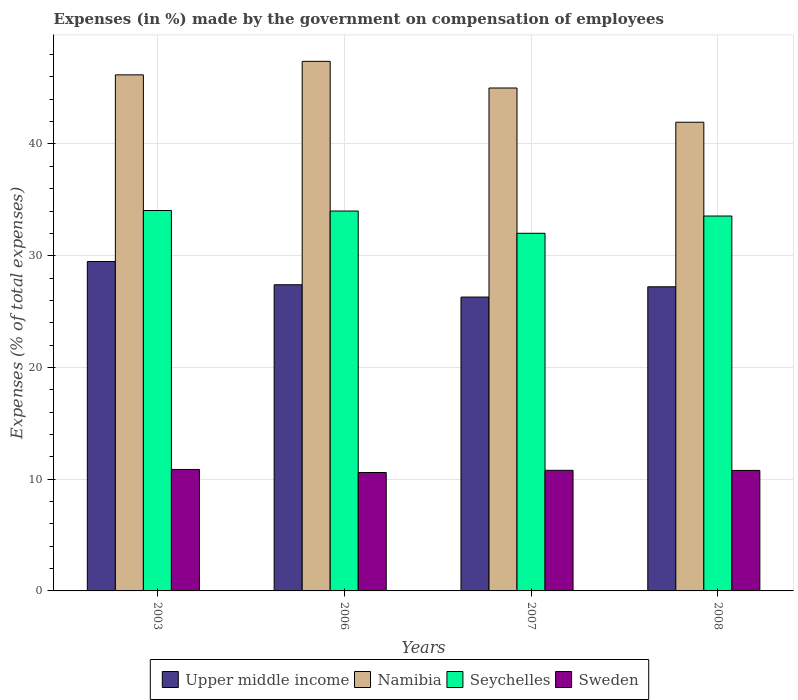How many different coloured bars are there?
Provide a succinct answer. 4. How many groups of bars are there?
Give a very brief answer. 4. How many bars are there on the 4th tick from the left?
Your answer should be compact. 4. How many bars are there on the 4th tick from the right?
Your answer should be very brief. 4. What is the percentage of expenses made by the government on compensation of employees in Upper middle income in 2007?
Offer a terse response. 26.3. Across all years, what is the maximum percentage of expenses made by the government on compensation of employees in Sweden?
Offer a terse response. 10.87. Across all years, what is the minimum percentage of expenses made by the government on compensation of employees in Upper middle income?
Offer a terse response. 26.3. In which year was the percentage of expenses made by the government on compensation of employees in Sweden maximum?
Your answer should be compact. 2003. In which year was the percentage of expenses made by the government on compensation of employees in Upper middle income minimum?
Provide a succinct answer. 2007. What is the total percentage of expenses made by the government on compensation of employees in Sweden in the graph?
Your answer should be very brief. 43.05. What is the difference between the percentage of expenses made by the government on compensation of employees in Seychelles in 2003 and that in 2007?
Offer a very short reply. 2.04. What is the difference between the percentage of expenses made by the government on compensation of employees in Upper middle income in 2007 and the percentage of expenses made by the government on compensation of employees in Sweden in 2003?
Offer a very short reply. 15.43. What is the average percentage of expenses made by the government on compensation of employees in Sweden per year?
Keep it short and to the point. 10.76. In the year 2006, what is the difference between the percentage of expenses made by the government on compensation of employees in Sweden and percentage of expenses made by the government on compensation of employees in Namibia?
Give a very brief answer. -36.8. In how many years, is the percentage of expenses made by the government on compensation of employees in Seychelles greater than 14 %?
Make the answer very short. 4. What is the ratio of the percentage of expenses made by the government on compensation of employees in Upper middle income in 2003 to that in 2007?
Make the answer very short. 1.12. Is the percentage of expenses made by the government on compensation of employees in Sweden in 2003 less than that in 2007?
Your response must be concise. No. Is the difference between the percentage of expenses made by the government on compensation of employees in Sweden in 2003 and 2008 greater than the difference between the percentage of expenses made by the government on compensation of employees in Namibia in 2003 and 2008?
Offer a terse response. No. What is the difference between the highest and the second highest percentage of expenses made by the government on compensation of employees in Namibia?
Ensure brevity in your answer.  1.21. What is the difference between the highest and the lowest percentage of expenses made by the government on compensation of employees in Seychelles?
Your answer should be compact. 2.04. In how many years, is the percentage of expenses made by the government on compensation of employees in Namibia greater than the average percentage of expenses made by the government on compensation of employees in Namibia taken over all years?
Provide a succinct answer. 2. Is the sum of the percentage of expenses made by the government on compensation of employees in Seychelles in 2006 and 2008 greater than the maximum percentage of expenses made by the government on compensation of employees in Namibia across all years?
Your answer should be very brief. Yes. Is it the case that in every year, the sum of the percentage of expenses made by the government on compensation of employees in Sweden and percentage of expenses made by the government on compensation of employees in Namibia is greater than the sum of percentage of expenses made by the government on compensation of employees in Seychelles and percentage of expenses made by the government on compensation of employees in Upper middle income?
Give a very brief answer. No. What does the 4th bar from the left in 2008 represents?
Make the answer very short. Sweden. What does the 2nd bar from the right in 2006 represents?
Offer a terse response. Seychelles. How many bars are there?
Your response must be concise. 16. Are all the bars in the graph horizontal?
Give a very brief answer. No. How many years are there in the graph?
Your response must be concise. 4. Are the values on the major ticks of Y-axis written in scientific E-notation?
Make the answer very short. No. Does the graph contain any zero values?
Provide a short and direct response. No. How are the legend labels stacked?
Your answer should be very brief. Horizontal. What is the title of the graph?
Offer a terse response. Expenses (in %) made by the government on compensation of employees. What is the label or title of the Y-axis?
Provide a short and direct response. Expenses (% of total expenses). What is the Expenses (% of total expenses) of Upper middle income in 2003?
Provide a succinct answer. 29.48. What is the Expenses (% of total expenses) in Namibia in 2003?
Offer a very short reply. 46.19. What is the Expenses (% of total expenses) in Seychelles in 2003?
Your answer should be compact. 34.05. What is the Expenses (% of total expenses) in Sweden in 2003?
Offer a terse response. 10.87. What is the Expenses (% of total expenses) in Upper middle income in 2006?
Keep it short and to the point. 27.4. What is the Expenses (% of total expenses) of Namibia in 2006?
Give a very brief answer. 47.4. What is the Expenses (% of total expenses) in Seychelles in 2006?
Your response must be concise. 34. What is the Expenses (% of total expenses) in Sweden in 2006?
Make the answer very short. 10.6. What is the Expenses (% of total expenses) in Upper middle income in 2007?
Ensure brevity in your answer.  26.3. What is the Expenses (% of total expenses) of Namibia in 2007?
Give a very brief answer. 45.01. What is the Expenses (% of total expenses) in Seychelles in 2007?
Your response must be concise. 32.01. What is the Expenses (% of total expenses) in Sweden in 2007?
Give a very brief answer. 10.79. What is the Expenses (% of total expenses) in Upper middle income in 2008?
Give a very brief answer. 27.22. What is the Expenses (% of total expenses) of Namibia in 2008?
Provide a succinct answer. 41.95. What is the Expenses (% of total expenses) of Seychelles in 2008?
Offer a terse response. 33.55. What is the Expenses (% of total expenses) of Sweden in 2008?
Ensure brevity in your answer.  10.78. Across all years, what is the maximum Expenses (% of total expenses) in Upper middle income?
Give a very brief answer. 29.48. Across all years, what is the maximum Expenses (% of total expenses) of Namibia?
Provide a short and direct response. 47.4. Across all years, what is the maximum Expenses (% of total expenses) in Seychelles?
Make the answer very short. 34.05. Across all years, what is the maximum Expenses (% of total expenses) in Sweden?
Provide a succinct answer. 10.87. Across all years, what is the minimum Expenses (% of total expenses) in Upper middle income?
Make the answer very short. 26.3. Across all years, what is the minimum Expenses (% of total expenses) of Namibia?
Make the answer very short. 41.95. Across all years, what is the minimum Expenses (% of total expenses) in Seychelles?
Make the answer very short. 32.01. Across all years, what is the minimum Expenses (% of total expenses) in Sweden?
Your answer should be very brief. 10.6. What is the total Expenses (% of total expenses) of Upper middle income in the graph?
Keep it short and to the point. 110.4. What is the total Expenses (% of total expenses) in Namibia in the graph?
Your answer should be compact. 180.54. What is the total Expenses (% of total expenses) in Seychelles in the graph?
Your response must be concise. 133.61. What is the total Expenses (% of total expenses) in Sweden in the graph?
Make the answer very short. 43.05. What is the difference between the Expenses (% of total expenses) of Upper middle income in 2003 and that in 2006?
Offer a very short reply. 2.08. What is the difference between the Expenses (% of total expenses) in Namibia in 2003 and that in 2006?
Offer a very short reply. -1.21. What is the difference between the Expenses (% of total expenses) in Seychelles in 2003 and that in 2006?
Ensure brevity in your answer.  0.05. What is the difference between the Expenses (% of total expenses) in Sweden in 2003 and that in 2006?
Make the answer very short. 0.27. What is the difference between the Expenses (% of total expenses) of Upper middle income in 2003 and that in 2007?
Keep it short and to the point. 3.18. What is the difference between the Expenses (% of total expenses) in Namibia in 2003 and that in 2007?
Offer a very short reply. 1.18. What is the difference between the Expenses (% of total expenses) of Seychelles in 2003 and that in 2007?
Provide a short and direct response. 2.04. What is the difference between the Expenses (% of total expenses) in Sweden in 2003 and that in 2007?
Provide a succinct answer. 0.08. What is the difference between the Expenses (% of total expenses) in Upper middle income in 2003 and that in 2008?
Make the answer very short. 2.26. What is the difference between the Expenses (% of total expenses) of Namibia in 2003 and that in 2008?
Ensure brevity in your answer.  4.24. What is the difference between the Expenses (% of total expenses) in Seychelles in 2003 and that in 2008?
Give a very brief answer. 0.49. What is the difference between the Expenses (% of total expenses) in Sweden in 2003 and that in 2008?
Offer a terse response. 0.09. What is the difference between the Expenses (% of total expenses) of Upper middle income in 2006 and that in 2007?
Give a very brief answer. 1.1. What is the difference between the Expenses (% of total expenses) of Namibia in 2006 and that in 2007?
Your response must be concise. 2.39. What is the difference between the Expenses (% of total expenses) in Seychelles in 2006 and that in 2007?
Offer a very short reply. 1.99. What is the difference between the Expenses (% of total expenses) in Sweden in 2006 and that in 2007?
Ensure brevity in your answer.  -0.2. What is the difference between the Expenses (% of total expenses) of Upper middle income in 2006 and that in 2008?
Provide a short and direct response. 0.18. What is the difference between the Expenses (% of total expenses) in Namibia in 2006 and that in 2008?
Offer a terse response. 5.45. What is the difference between the Expenses (% of total expenses) in Seychelles in 2006 and that in 2008?
Your answer should be very brief. 0.45. What is the difference between the Expenses (% of total expenses) of Sweden in 2006 and that in 2008?
Your answer should be compact. -0.19. What is the difference between the Expenses (% of total expenses) in Upper middle income in 2007 and that in 2008?
Your answer should be compact. -0.92. What is the difference between the Expenses (% of total expenses) of Namibia in 2007 and that in 2008?
Give a very brief answer. 3.06. What is the difference between the Expenses (% of total expenses) of Seychelles in 2007 and that in 2008?
Give a very brief answer. -1.55. What is the difference between the Expenses (% of total expenses) of Sweden in 2007 and that in 2008?
Offer a terse response. 0.01. What is the difference between the Expenses (% of total expenses) of Upper middle income in 2003 and the Expenses (% of total expenses) of Namibia in 2006?
Give a very brief answer. -17.91. What is the difference between the Expenses (% of total expenses) in Upper middle income in 2003 and the Expenses (% of total expenses) in Seychelles in 2006?
Your answer should be compact. -4.52. What is the difference between the Expenses (% of total expenses) of Upper middle income in 2003 and the Expenses (% of total expenses) of Sweden in 2006?
Keep it short and to the point. 18.89. What is the difference between the Expenses (% of total expenses) of Namibia in 2003 and the Expenses (% of total expenses) of Seychelles in 2006?
Your response must be concise. 12.19. What is the difference between the Expenses (% of total expenses) of Namibia in 2003 and the Expenses (% of total expenses) of Sweden in 2006?
Provide a succinct answer. 35.59. What is the difference between the Expenses (% of total expenses) of Seychelles in 2003 and the Expenses (% of total expenses) of Sweden in 2006?
Your response must be concise. 23.45. What is the difference between the Expenses (% of total expenses) of Upper middle income in 2003 and the Expenses (% of total expenses) of Namibia in 2007?
Your answer should be very brief. -15.53. What is the difference between the Expenses (% of total expenses) of Upper middle income in 2003 and the Expenses (% of total expenses) of Seychelles in 2007?
Ensure brevity in your answer.  -2.52. What is the difference between the Expenses (% of total expenses) of Upper middle income in 2003 and the Expenses (% of total expenses) of Sweden in 2007?
Offer a terse response. 18.69. What is the difference between the Expenses (% of total expenses) in Namibia in 2003 and the Expenses (% of total expenses) in Seychelles in 2007?
Ensure brevity in your answer.  14.18. What is the difference between the Expenses (% of total expenses) in Namibia in 2003 and the Expenses (% of total expenses) in Sweden in 2007?
Offer a very short reply. 35.39. What is the difference between the Expenses (% of total expenses) of Seychelles in 2003 and the Expenses (% of total expenses) of Sweden in 2007?
Your response must be concise. 23.25. What is the difference between the Expenses (% of total expenses) of Upper middle income in 2003 and the Expenses (% of total expenses) of Namibia in 2008?
Keep it short and to the point. -12.46. What is the difference between the Expenses (% of total expenses) in Upper middle income in 2003 and the Expenses (% of total expenses) in Seychelles in 2008?
Make the answer very short. -4.07. What is the difference between the Expenses (% of total expenses) of Upper middle income in 2003 and the Expenses (% of total expenses) of Sweden in 2008?
Your answer should be compact. 18.7. What is the difference between the Expenses (% of total expenses) in Namibia in 2003 and the Expenses (% of total expenses) in Seychelles in 2008?
Give a very brief answer. 12.63. What is the difference between the Expenses (% of total expenses) in Namibia in 2003 and the Expenses (% of total expenses) in Sweden in 2008?
Keep it short and to the point. 35.4. What is the difference between the Expenses (% of total expenses) in Seychelles in 2003 and the Expenses (% of total expenses) in Sweden in 2008?
Provide a short and direct response. 23.26. What is the difference between the Expenses (% of total expenses) in Upper middle income in 2006 and the Expenses (% of total expenses) in Namibia in 2007?
Ensure brevity in your answer.  -17.61. What is the difference between the Expenses (% of total expenses) of Upper middle income in 2006 and the Expenses (% of total expenses) of Seychelles in 2007?
Offer a very short reply. -4.61. What is the difference between the Expenses (% of total expenses) in Upper middle income in 2006 and the Expenses (% of total expenses) in Sweden in 2007?
Your answer should be compact. 16.61. What is the difference between the Expenses (% of total expenses) in Namibia in 2006 and the Expenses (% of total expenses) in Seychelles in 2007?
Provide a short and direct response. 15.39. What is the difference between the Expenses (% of total expenses) of Namibia in 2006 and the Expenses (% of total expenses) of Sweden in 2007?
Make the answer very short. 36.6. What is the difference between the Expenses (% of total expenses) of Seychelles in 2006 and the Expenses (% of total expenses) of Sweden in 2007?
Keep it short and to the point. 23.21. What is the difference between the Expenses (% of total expenses) in Upper middle income in 2006 and the Expenses (% of total expenses) in Namibia in 2008?
Your answer should be compact. -14.55. What is the difference between the Expenses (% of total expenses) in Upper middle income in 2006 and the Expenses (% of total expenses) in Seychelles in 2008?
Offer a very short reply. -6.15. What is the difference between the Expenses (% of total expenses) in Upper middle income in 2006 and the Expenses (% of total expenses) in Sweden in 2008?
Provide a succinct answer. 16.62. What is the difference between the Expenses (% of total expenses) of Namibia in 2006 and the Expenses (% of total expenses) of Seychelles in 2008?
Your answer should be compact. 13.84. What is the difference between the Expenses (% of total expenses) of Namibia in 2006 and the Expenses (% of total expenses) of Sweden in 2008?
Give a very brief answer. 36.61. What is the difference between the Expenses (% of total expenses) of Seychelles in 2006 and the Expenses (% of total expenses) of Sweden in 2008?
Your response must be concise. 23.22. What is the difference between the Expenses (% of total expenses) of Upper middle income in 2007 and the Expenses (% of total expenses) of Namibia in 2008?
Your response must be concise. -15.65. What is the difference between the Expenses (% of total expenses) in Upper middle income in 2007 and the Expenses (% of total expenses) in Seychelles in 2008?
Give a very brief answer. -7.25. What is the difference between the Expenses (% of total expenses) in Upper middle income in 2007 and the Expenses (% of total expenses) in Sweden in 2008?
Offer a terse response. 15.52. What is the difference between the Expenses (% of total expenses) of Namibia in 2007 and the Expenses (% of total expenses) of Seychelles in 2008?
Your answer should be compact. 11.46. What is the difference between the Expenses (% of total expenses) of Namibia in 2007 and the Expenses (% of total expenses) of Sweden in 2008?
Your answer should be compact. 34.23. What is the difference between the Expenses (% of total expenses) of Seychelles in 2007 and the Expenses (% of total expenses) of Sweden in 2008?
Keep it short and to the point. 21.22. What is the average Expenses (% of total expenses) in Upper middle income per year?
Your answer should be very brief. 27.6. What is the average Expenses (% of total expenses) of Namibia per year?
Provide a short and direct response. 45.14. What is the average Expenses (% of total expenses) in Seychelles per year?
Provide a succinct answer. 33.4. What is the average Expenses (% of total expenses) in Sweden per year?
Give a very brief answer. 10.76. In the year 2003, what is the difference between the Expenses (% of total expenses) of Upper middle income and Expenses (% of total expenses) of Namibia?
Provide a succinct answer. -16.7. In the year 2003, what is the difference between the Expenses (% of total expenses) of Upper middle income and Expenses (% of total expenses) of Seychelles?
Keep it short and to the point. -4.56. In the year 2003, what is the difference between the Expenses (% of total expenses) in Upper middle income and Expenses (% of total expenses) in Sweden?
Ensure brevity in your answer.  18.61. In the year 2003, what is the difference between the Expenses (% of total expenses) of Namibia and Expenses (% of total expenses) of Seychelles?
Your answer should be very brief. 12.14. In the year 2003, what is the difference between the Expenses (% of total expenses) of Namibia and Expenses (% of total expenses) of Sweden?
Make the answer very short. 35.32. In the year 2003, what is the difference between the Expenses (% of total expenses) of Seychelles and Expenses (% of total expenses) of Sweden?
Your answer should be compact. 23.18. In the year 2006, what is the difference between the Expenses (% of total expenses) of Upper middle income and Expenses (% of total expenses) of Namibia?
Keep it short and to the point. -19.99. In the year 2006, what is the difference between the Expenses (% of total expenses) of Upper middle income and Expenses (% of total expenses) of Seychelles?
Offer a very short reply. -6.6. In the year 2006, what is the difference between the Expenses (% of total expenses) in Upper middle income and Expenses (% of total expenses) in Sweden?
Offer a very short reply. 16.8. In the year 2006, what is the difference between the Expenses (% of total expenses) of Namibia and Expenses (% of total expenses) of Seychelles?
Ensure brevity in your answer.  13.4. In the year 2006, what is the difference between the Expenses (% of total expenses) in Namibia and Expenses (% of total expenses) in Sweden?
Ensure brevity in your answer.  36.8. In the year 2006, what is the difference between the Expenses (% of total expenses) in Seychelles and Expenses (% of total expenses) in Sweden?
Your response must be concise. 23.4. In the year 2007, what is the difference between the Expenses (% of total expenses) of Upper middle income and Expenses (% of total expenses) of Namibia?
Ensure brevity in your answer.  -18.71. In the year 2007, what is the difference between the Expenses (% of total expenses) of Upper middle income and Expenses (% of total expenses) of Seychelles?
Provide a short and direct response. -5.71. In the year 2007, what is the difference between the Expenses (% of total expenses) of Upper middle income and Expenses (% of total expenses) of Sweden?
Provide a short and direct response. 15.5. In the year 2007, what is the difference between the Expenses (% of total expenses) in Namibia and Expenses (% of total expenses) in Seychelles?
Make the answer very short. 13. In the year 2007, what is the difference between the Expenses (% of total expenses) of Namibia and Expenses (% of total expenses) of Sweden?
Your response must be concise. 34.22. In the year 2007, what is the difference between the Expenses (% of total expenses) in Seychelles and Expenses (% of total expenses) in Sweden?
Keep it short and to the point. 21.21. In the year 2008, what is the difference between the Expenses (% of total expenses) in Upper middle income and Expenses (% of total expenses) in Namibia?
Ensure brevity in your answer.  -14.73. In the year 2008, what is the difference between the Expenses (% of total expenses) in Upper middle income and Expenses (% of total expenses) in Seychelles?
Offer a terse response. -6.33. In the year 2008, what is the difference between the Expenses (% of total expenses) in Upper middle income and Expenses (% of total expenses) in Sweden?
Your answer should be compact. 16.44. In the year 2008, what is the difference between the Expenses (% of total expenses) of Namibia and Expenses (% of total expenses) of Seychelles?
Ensure brevity in your answer.  8.39. In the year 2008, what is the difference between the Expenses (% of total expenses) in Namibia and Expenses (% of total expenses) in Sweden?
Ensure brevity in your answer.  31.16. In the year 2008, what is the difference between the Expenses (% of total expenses) of Seychelles and Expenses (% of total expenses) of Sweden?
Make the answer very short. 22.77. What is the ratio of the Expenses (% of total expenses) in Upper middle income in 2003 to that in 2006?
Your answer should be compact. 1.08. What is the ratio of the Expenses (% of total expenses) of Namibia in 2003 to that in 2006?
Your answer should be very brief. 0.97. What is the ratio of the Expenses (% of total expenses) of Sweden in 2003 to that in 2006?
Offer a terse response. 1.03. What is the ratio of the Expenses (% of total expenses) of Upper middle income in 2003 to that in 2007?
Your response must be concise. 1.12. What is the ratio of the Expenses (% of total expenses) of Namibia in 2003 to that in 2007?
Ensure brevity in your answer.  1.03. What is the ratio of the Expenses (% of total expenses) in Seychelles in 2003 to that in 2007?
Your response must be concise. 1.06. What is the ratio of the Expenses (% of total expenses) in Upper middle income in 2003 to that in 2008?
Give a very brief answer. 1.08. What is the ratio of the Expenses (% of total expenses) in Namibia in 2003 to that in 2008?
Your answer should be compact. 1.1. What is the ratio of the Expenses (% of total expenses) of Seychelles in 2003 to that in 2008?
Make the answer very short. 1.01. What is the ratio of the Expenses (% of total expenses) in Sweden in 2003 to that in 2008?
Your answer should be compact. 1.01. What is the ratio of the Expenses (% of total expenses) in Upper middle income in 2006 to that in 2007?
Keep it short and to the point. 1.04. What is the ratio of the Expenses (% of total expenses) in Namibia in 2006 to that in 2007?
Your response must be concise. 1.05. What is the ratio of the Expenses (% of total expenses) of Seychelles in 2006 to that in 2007?
Provide a short and direct response. 1.06. What is the ratio of the Expenses (% of total expenses) of Sweden in 2006 to that in 2007?
Ensure brevity in your answer.  0.98. What is the ratio of the Expenses (% of total expenses) in Upper middle income in 2006 to that in 2008?
Give a very brief answer. 1.01. What is the ratio of the Expenses (% of total expenses) of Namibia in 2006 to that in 2008?
Your answer should be compact. 1.13. What is the ratio of the Expenses (% of total expenses) of Seychelles in 2006 to that in 2008?
Make the answer very short. 1.01. What is the ratio of the Expenses (% of total expenses) of Sweden in 2006 to that in 2008?
Provide a short and direct response. 0.98. What is the ratio of the Expenses (% of total expenses) of Upper middle income in 2007 to that in 2008?
Keep it short and to the point. 0.97. What is the ratio of the Expenses (% of total expenses) in Namibia in 2007 to that in 2008?
Your answer should be compact. 1.07. What is the ratio of the Expenses (% of total expenses) of Seychelles in 2007 to that in 2008?
Make the answer very short. 0.95. What is the difference between the highest and the second highest Expenses (% of total expenses) in Upper middle income?
Your answer should be compact. 2.08. What is the difference between the highest and the second highest Expenses (% of total expenses) in Namibia?
Offer a very short reply. 1.21. What is the difference between the highest and the second highest Expenses (% of total expenses) of Seychelles?
Make the answer very short. 0.05. What is the difference between the highest and the second highest Expenses (% of total expenses) in Sweden?
Offer a terse response. 0.08. What is the difference between the highest and the lowest Expenses (% of total expenses) in Upper middle income?
Offer a terse response. 3.18. What is the difference between the highest and the lowest Expenses (% of total expenses) of Namibia?
Offer a terse response. 5.45. What is the difference between the highest and the lowest Expenses (% of total expenses) in Seychelles?
Your answer should be very brief. 2.04. What is the difference between the highest and the lowest Expenses (% of total expenses) of Sweden?
Ensure brevity in your answer.  0.27. 